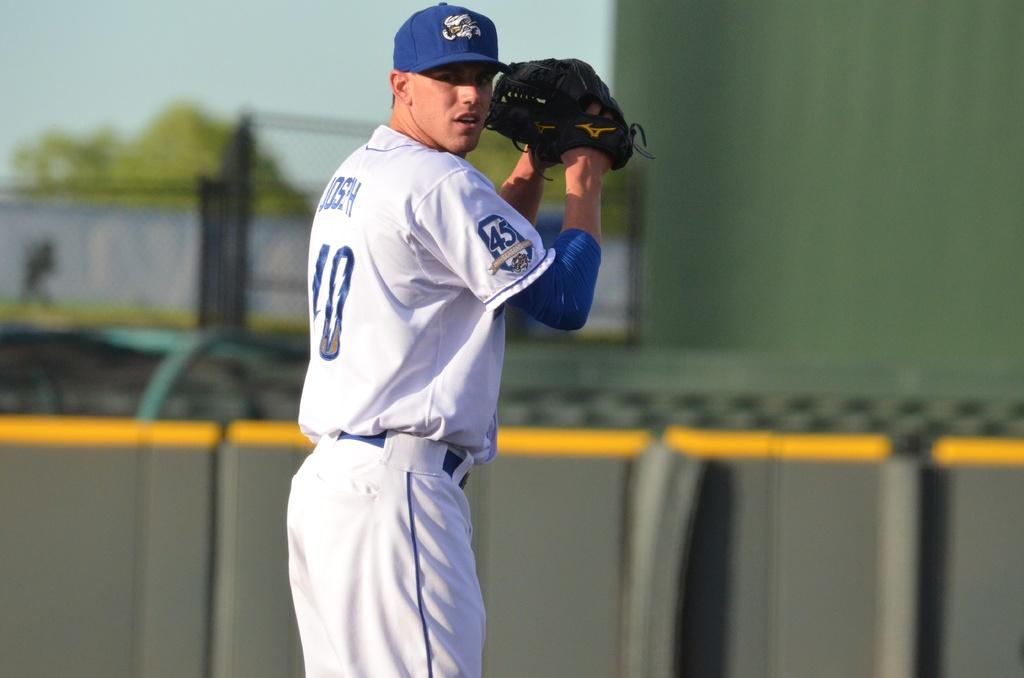<image>
Summarize the visual content of the image. Player number 10 winds up in preparation for throwing a pitch. 